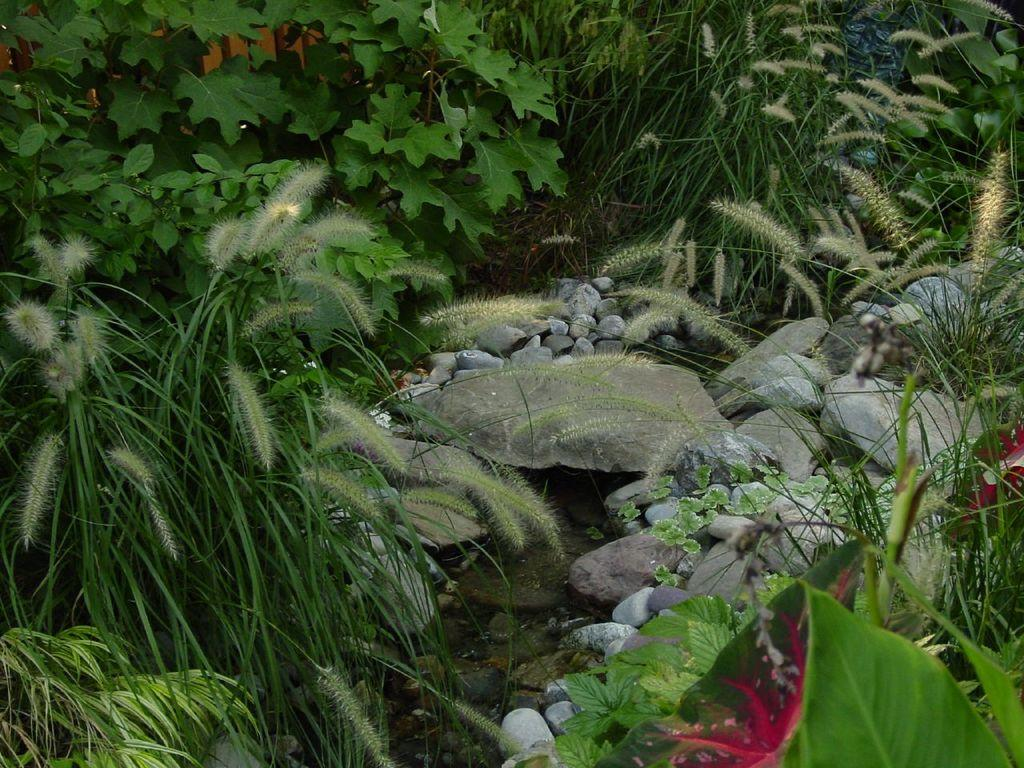What type of living organisms can be seen in the image? Plants can be seen in the image. What other objects are present in the image besides plants? There are stones in the image. What type of trucks can be seen driving through the plants in the image? There are no trucks present in the image; it only features plants and stones. What kind of mask is being worn by the plants in the image? There are no masks present in the image, as plants do not wear masks. 